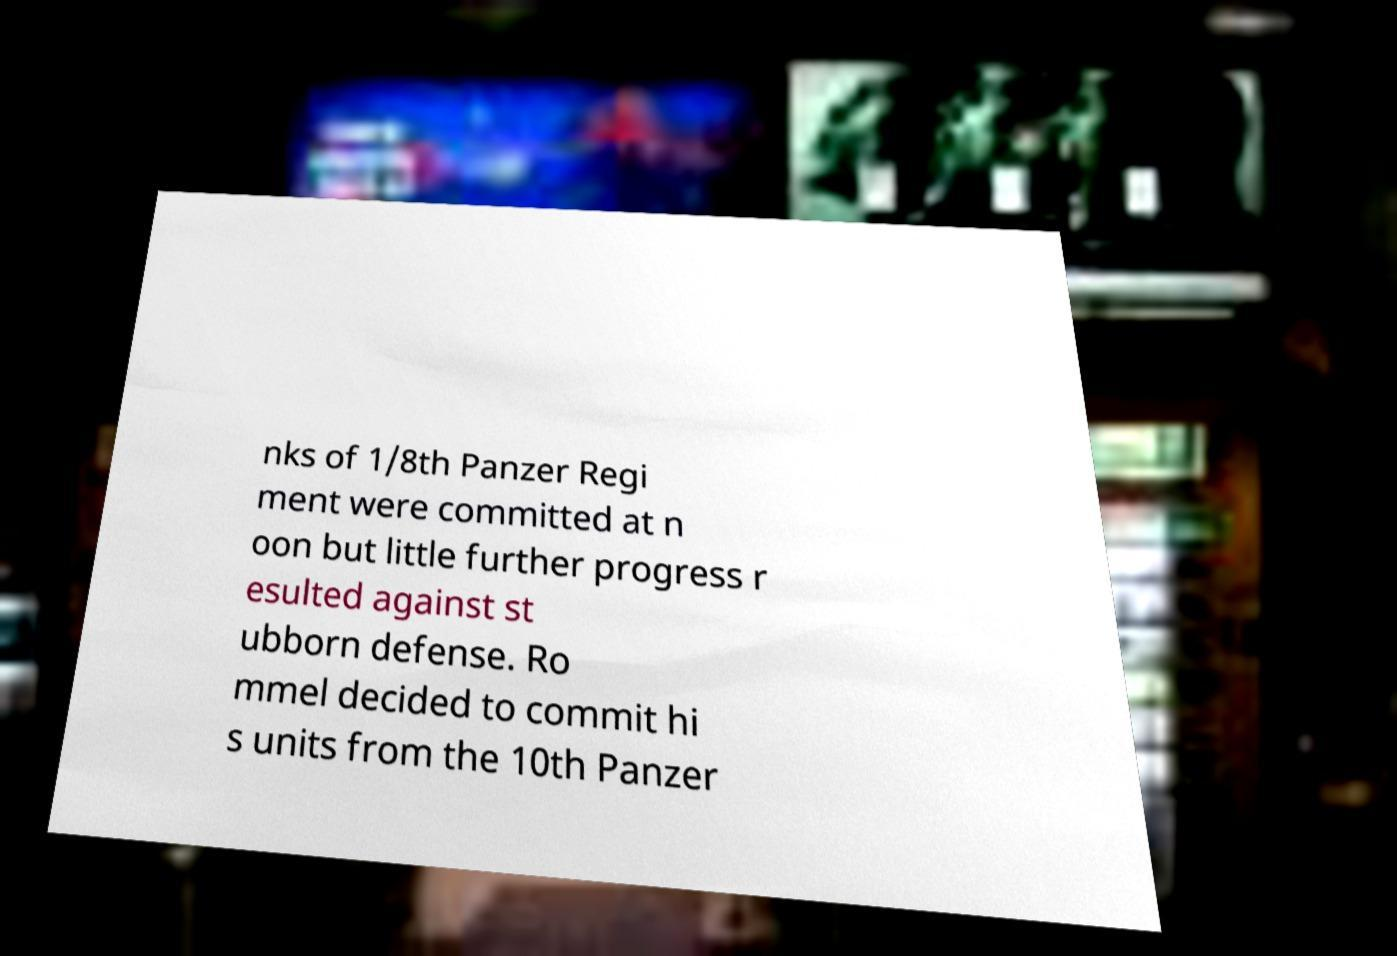Please read and relay the text visible in this image. What does it say? nks of 1/8th Panzer Regi ment were committed at n oon but little further progress r esulted against st ubborn defense. Ro mmel decided to commit hi s units from the 10th Panzer 